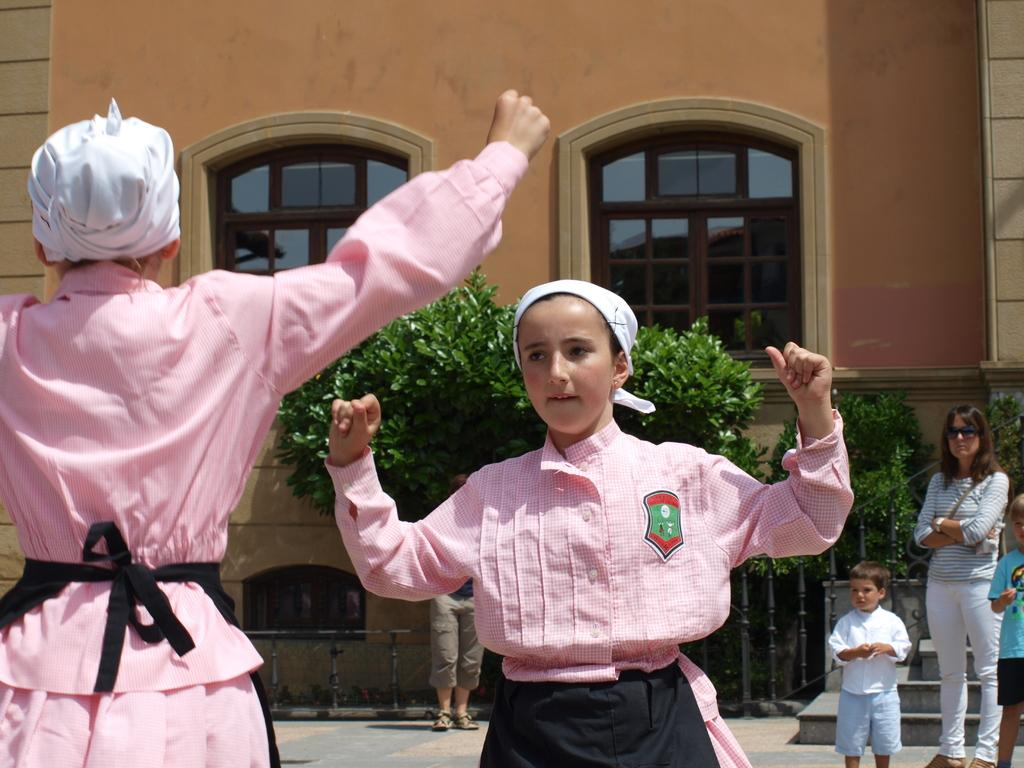What is happening in the image? There are people standing in the image. Can you describe the clothing of two of the people? Two of the people are wearing the same color of dress. What can be seen in the background of the image? There are trees and a building in the background of the image, with windows visible. What type of jar can be seen in the aftermath of the event in the image? There is no jar or event present in the image; it simply shows people standing with a background of trees and a building. 